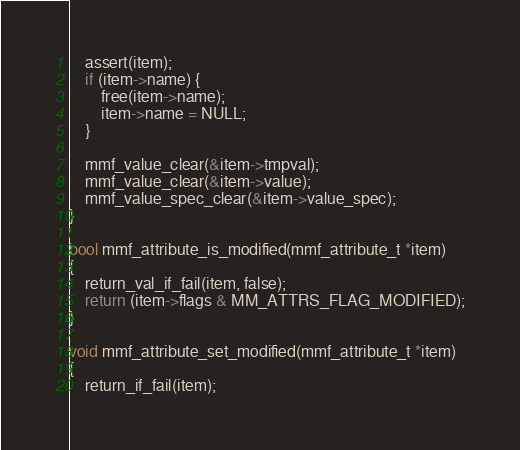<code> <loc_0><loc_0><loc_500><loc_500><_C_>	assert(item);
	if (item->name) {
		free(item->name);
		item->name = NULL;
	}

	mmf_value_clear(&item->tmpval);
	mmf_value_clear(&item->value);
	mmf_value_spec_clear(&item->value_spec);
}

bool mmf_attribute_is_modified(mmf_attribute_t *item)
{
	return_val_if_fail(item, false);
	return (item->flags & MM_ATTRS_FLAG_MODIFIED);
}

void mmf_attribute_set_modified(mmf_attribute_t *item)
{
	return_if_fail(item);</code> 